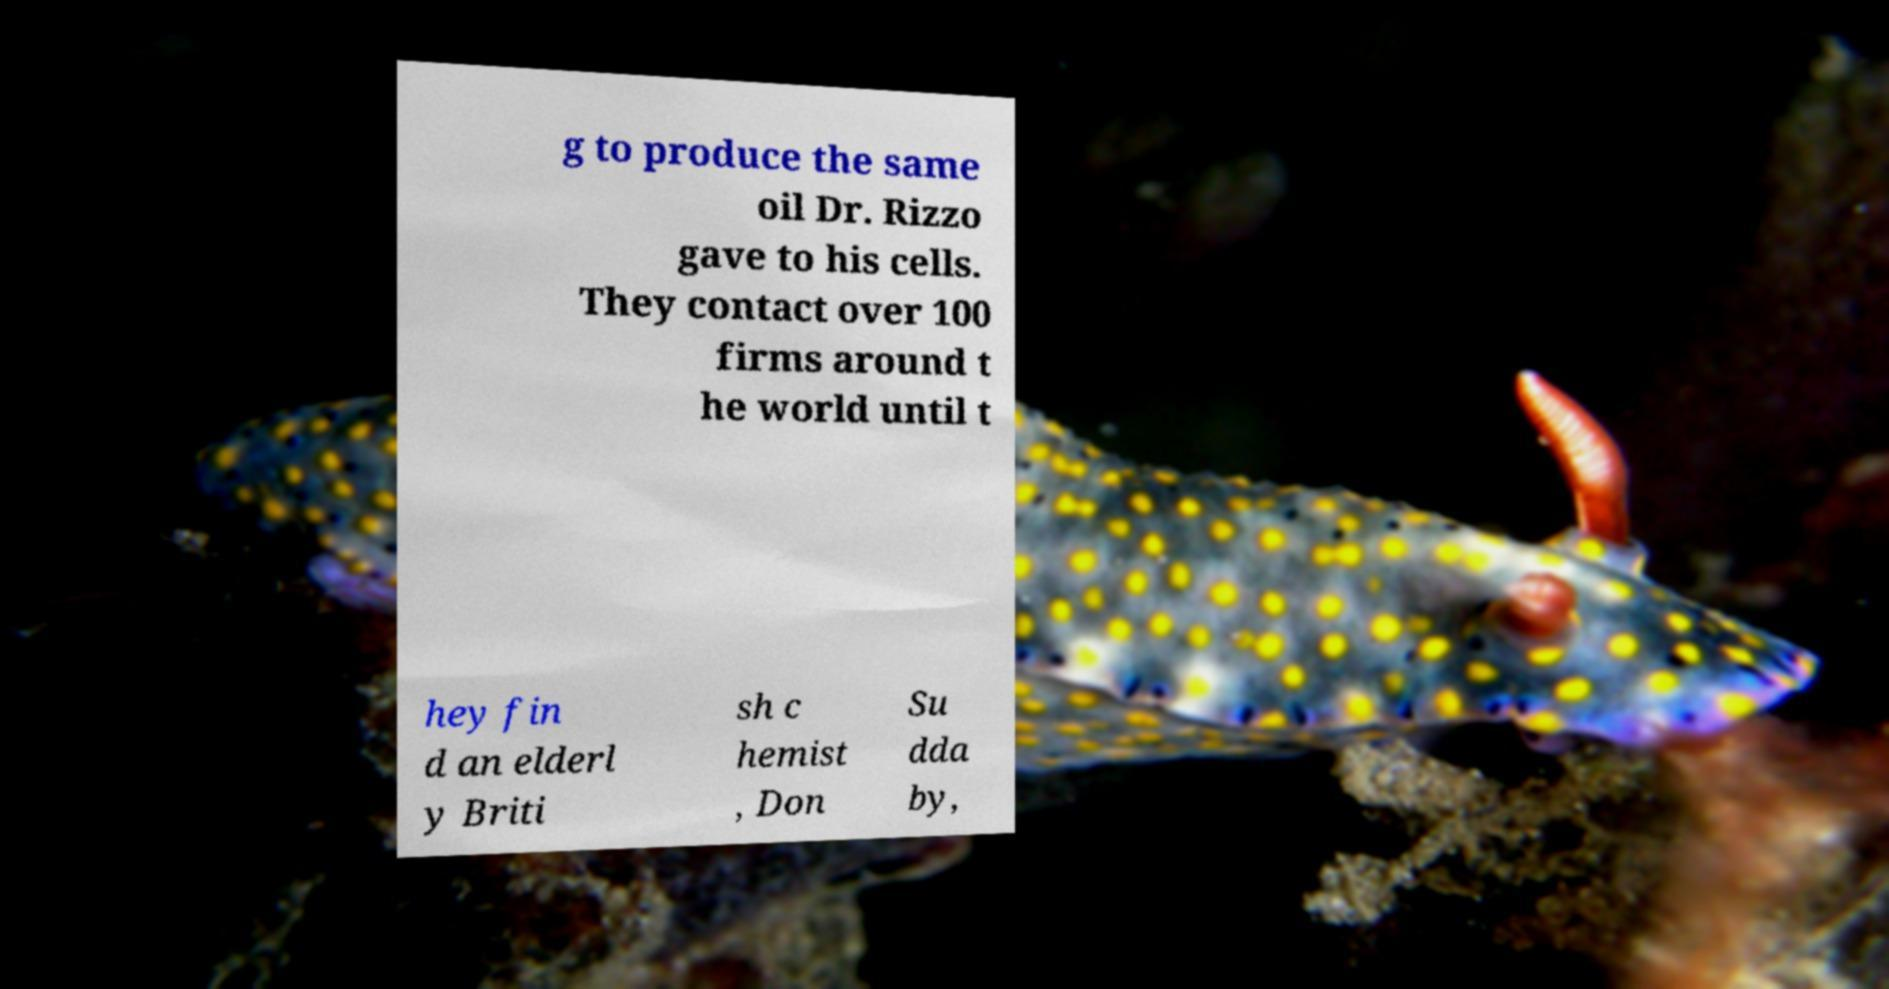What messages or text are displayed in this image? I need them in a readable, typed format. g to produce the same oil Dr. Rizzo gave to his cells. They contact over 100 firms around t he world until t hey fin d an elderl y Briti sh c hemist , Don Su dda by, 